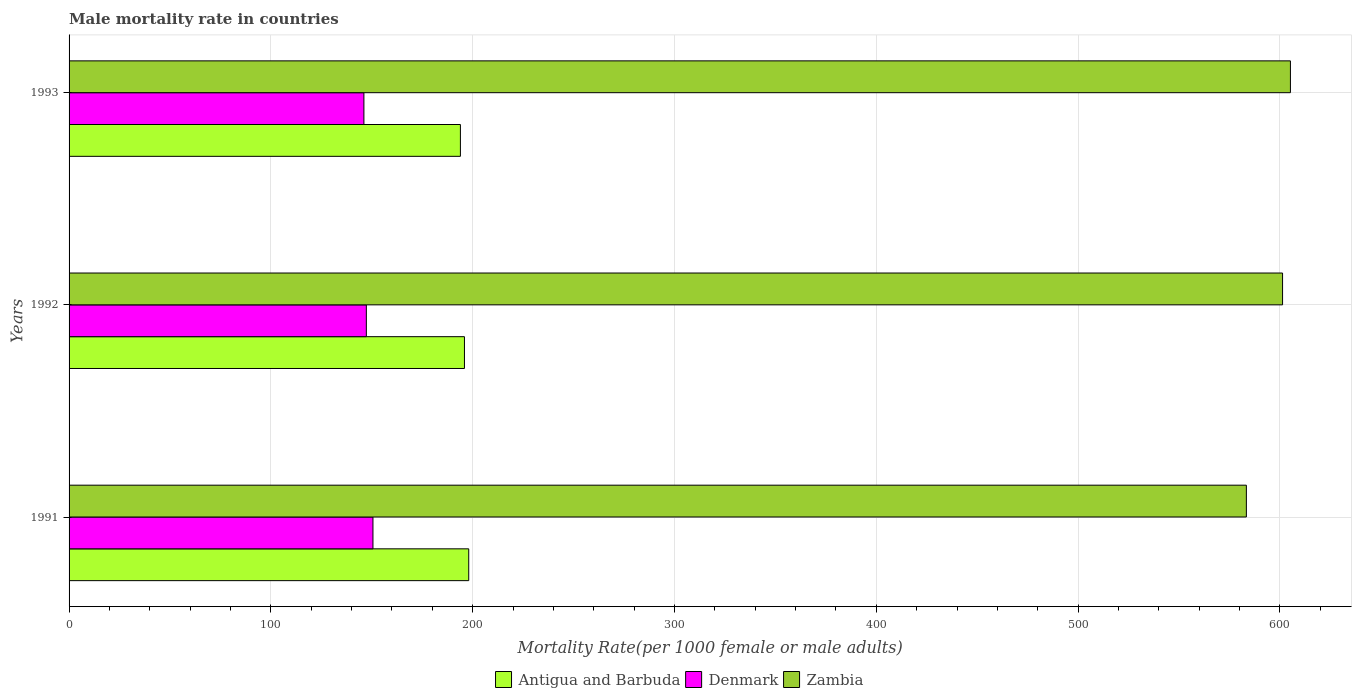How many different coloured bars are there?
Keep it short and to the point. 3. How many bars are there on the 3rd tick from the top?
Your answer should be very brief. 3. What is the label of the 3rd group of bars from the top?
Give a very brief answer. 1991. What is the male mortality rate in Denmark in 1991?
Your answer should be very brief. 150.57. Across all years, what is the maximum male mortality rate in Antigua and Barbuda?
Your answer should be very brief. 198.03. Across all years, what is the minimum male mortality rate in Denmark?
Give a very brief answer. 146.09. What is the total male mortality rate in Antigua and Barbuda in the graph?
Your answer should be very brief. 587.86. What is the difference between the male mortality rate in Denmark in 1991 and that in 1993?
Ensure brevity in your answer.  4.48. What is the difference between the male mortality rate in Denmark in 1993 and the male mortality rate in Zambia in 1991?
Your answer should be very brief. -437.27. What is the average male mortality rate in Denmark per year?
Your response must be concise. 147.99. In the year 1991, what is the difference between the male mortality rate in Antigua and Barbuda and male mortality rate in Denmark?
Your response must be concise. 47.46. In how many years, is the male mortality rate in Zambia greater than 140 ?
Your answer should be very brief. 3. What is the ratio of the male mortality rate in Denmark in 1992 to that in 1993?
Keep it short and to the point. 1.01. Is the male mortality rate in Zambia in 1992 less than that in 1993?
Keep it short and to the point. Yes. Is the difference between the male mortality rate in Antigua and Barbuda in 1991 and 1992 greater than the difference between the male mortality rate in Denmark in 1991 and 1992?
Offer a terse response. No. What is the difference between the highest and the second highest male mortality rate in Zambia?
Your answer should be compact. 3.9. What is the difference between the highest and the lowest male mortality rate in Denmark?
Your response must be concise. 4.48. Is the sum of the male mortality rate in Denmark in 1991 and 1992 greater than the maximum male mortality rate in Zambia across all years?
Ensure brevity in your answer.  No. What does the 3rd bar from the top in 1991 represents?
Provide a short and direct response. Antigua and Barbuda. What does the 3rd bar from the bottom in 1991 represents?
Ensure brevity in your answer.  Zambia. Are all the bars in the graph horizontal?
Keep it short and to the point. Yes. How many years are there in the graph?
Provide a short and direct response. 3. Does the graph contain any zero values?
Your answer should be very brief. No. Does the graph contain grids?
Your response must be concise. Yes. Where does the legend appear in the graph?
Offer a terse response. Bottom center. How many legend labels are there?
Your answer should be very brief. 3. What is the title of the graph?
Provide a short and direct response. Male mortality rate in countries. What is the label or title of the X-axis?
Offer a terse response. Mortality Rate(per 1000 female or male adults). What is the Mortality Rate(per 1000 female or male adults) in Antigua and Barbuda in 1991?
Your response must be concise. 198.03. What is the Mortality Rate(per 1000 female or male adults) in Denmark in 1991?
Offer a very short reply. 150.57. What is the Mortality Rate(per 1000 female or male adults) in Zambia in 1991?
Your answer should be compact. 583.36. What is the Mortality Rate(per 1000 female or male adults) of Antigua and Barbuda in 1992?
Ensure brevity in your answer.  195.91. What is the Mortality Rate(per 1000 female or male adults) in Denmark in 1992?
Keep it short and to the point. 147.3. What is the Mortality Rate(per 1000 female or male adults) of Zambia in 1992?
Make the answer very short. 601.29. What is the Mortality Rate(per 1000 female or male adults) in Antigua and Barbuda in 1993?
Your answer should be compact. 193.91. What is the Mortality Rate(per 1000 female or male adults) of Denmark in 1993?
Keep it short and to the point. 146.09. What is the Mortality Rate(per 1000 female or male adults) of Zambia in 1993?
Offer a very short reply. 605.19. Across all years, what is the maximum Mortality Rate(per 1000 female or male adults) of Antigua and Barbuda?
Give a very brief answer. 198.03. Across all years, what is the maximum Mortality Rate(per 1000 female or male adults) in Denmark?
Your response must be concise. 150.57. Across all years, what is the maximum Mortality Rate(per 1000 female or male adults) of Zambia?
Make the answer very short. 605.19. Across all years, what is the minimum Mortality Rate(per 1000 female or male adults) in Antigua and Barbuda?
Your answer should be compact. 193.91. Across all years, what is the minimum Mortality Rate(per 1000 female or male adults) of Denmark?
Ensure brevity in your answer.  146.09. Across all years, what is the minimum Mortality Rate(per 1000 female or male adults) in Zambia?
Offer a very short reply. 583.36. What is the total Mortality Rate(per 1000 female or male adults) in Antigua and Barbuda in the graph?
Your answer should be compact. 587.86. What is the total Mortality Rate(per 1000 female or male adults) of Denmark in the graph?
Offer a terse response. 443.96. What is the total Mortality Rate(per 1000 female or male adults) of Zambia in the graph?
Make the answer very short. 1789.85. What is the difference between the Mortality Rate(per 1000 female or male adults) of Antigua and Barbuda in 1991 and that in 1992?
Make the answer very short. 2.12. What is the difference between the Mortality Rate(per 1000 female or male adults) in Denmark in 1991 and that in 1992?
Your answer should be compact. 3.28. What is the difference between the Mortality Rate(per 1000 female or male adults) of Zambia in 1991 and that in 1992?
Give a very brief answer. -17.93. What is the difference between the Mortality Rate(per 1000 female or male adults) of Antigua and Barbuda in 1991 and that in 1993?
Give a very brief answer. 4.12. What is the difference between the Mortality Rate(per 1000 female or male adults) in Denmark in 1991 and that in 1993?
Offer a terse response. 4.48. What is the difference between the Mortality Rate(per 1000 female or male adults) of Zambia in 1991 and that in 1993?
Your answer should be compact. -21.83. What is the difference between the Mortality Rate(per 1000 female or male adults) in Antigua and Barbuda in 1992 and that in 1993?
Keep it short and to the point. 2. What is the difference between the Mortality Rate(per 1000 female or male adults) of Denmark in 1992 and that in 1993?
Provide a short and direct response. 1.21. What is the difference between the Mortality Rate(per 1000 female or male adults) of Zambia in 1992 and that in 1993?
Provide a short and direct response. -3.9. What is the difference between the Mortality Rate(per 1000 female or male adults) of Antigua and Barbuda in 1991 and the Mortality Rate(per 1000 female or male adults) of Denmark in 1992?
Your answer should be very brief. 50.73. What is the difference between the Mortality Rate(per 1000 female or male adults) in Antigua and Barbuda in 1991 and the Mortality Rate(per 1000 female or male adults) in Zambia in 1992?
Keep it short and to the point. -403.26. What is the difference between the Mortality Rate(per 1000 female or male adults) in Denmark in 1991 and the Mortality Rate(per 1000 female or male adults) in Zambia in 1992?
Ensure brevity in your answer.  -450.72. What is the difference between the Mortality Rate(per 1000 female or male adults) in Antigua and Barbuda in 1991 and the Mortality Rate(per 1000 female or male adults) in Denmark in 1993?
Ensure brevity in your answer.  51.94. What is the difference between the Mortality Rate(per 1000 female or male adults) of Antigua and Barbuda in 1991 and the Mortality Rate(per 1000 female or male adults) of Zambia in 1993?
Ensure brevity in your answer.  -407.16. What is the difference between the Mortality Rate(per 1000 female or male adults) of Denmark in 1991 and the Mortality Rate(per 1000 female or male adults) of Zambia in 1993?
Give a very brief answer. -454.62. What is the difference between the Mortality Rate(per 1000 female or male adults) of Antigua and Barbuda in 1992 and the Mortality Rate(per 1000 female or male adults) of Denmark in 1993?
Give a very brief answer. 49.82. What is the difference between the Mortality Rate(per 1000 female or male adults) in Antigua and Barbuda in 1992 and the Mortality Rate(per 1000 female or male adults) in Zambia in 1993?
Keep it short and to the point. -409.28. What is the difference between the Mortality Rate(per 1000 female or male adults) of Denmark in 1992 and the Mortality Rate(per 1000 female or male adults) of Zambia in 1993?
Your response must be concise. -457.89. What is the average Mortality Rate(per 1000 female or male adults) of Antigua and Barbuda per year?
Give a very brief answer. 195.95. What is the average Mortality Rate(per 1000 female or male adults) in Denmark per year?
Your response must be concise. 147.99. What is the average Mortality Rate(per 1000 female or male adults) of Zambia per year?
Make the answer very short. 596.62. In the year 1991, what is the difference between the Mortality Rate(per 1000 female or male adults) of Antigua and Barbuda and Mortality Rate(per 1000 female or male adults) of Denmark?
Give a very brief answer. 47.46. In the year 1991, what is the difference between the Mortality Rate(per 1000 female or male adults) in Antigua and Barbuda and Mortality Rate(per 1000 female or male adults) in Zambia?
Ensure brevity in your answer.  -385.33. In the year 1991, what is the difference between the Mortality Rate(per 1000 female or male adults) in Denmark and Mortality Rate(per 1000 female or male adults) in Zambia?
Offer a terse response. -432.79. In the year 1992, what is the difference between the Mortality Rate(per 1000 female or male adults) of Antigua and Barbuda and Mortality Rate(per 1000 female or male adults) of Denmark?
Your response must be concise. 48.62. In the year 1992, what is the difference between the Mortality Rate(per 1000 female or male adults) in Antigua and Barbuda and Mortality Rate(per 1000 female or male adults) in Zambia?
Offer a very short reply. -405.38. In the year 1992, what is the difference between the Mortality Rate(per 1000 female or male adults) of Denmark and Mortality Rate(per 1000 female or male adults) of Zambia?
Offer a very short reply. -454. In the year 1993, what is the difference between the Mortality Rate(per 1000 female or male adults) in Antigua and Barbuda and Mortality Rate(per 1000 female or male adults) in Denmark?
Offer a terse response. 47.82. In the year 1993, what is the difference between the Mortality Rate(per 1000 female or male adults) in Antigua and Barbuda and Mortality Rate(per 1000 female or male adults) in Zambia?
Your answer should be very brief. -411.28. In the year 1993, what is the difference between the Mortality Rate(per 1000 female or male adults) of Denmark and Mortality Rate(per 1000 female or male adults) of Zambia?
Provide a short and direct response. -459.1. What is the ratio of the Mortality Rate(per 1000 female or male adults) in Antigua and Barbuda in 1991 to that in 1992?
Offer a terse response. 1.01. What is the ratio of the Mortality Rate(per 1000 female or male adults) of Denmark in 1991 to that in 1992?
Your answer should be compact. 1.02. What is the ratio of the Mortality Rate(per 1000 female or male adults) in Zambia in 1991 to that in 1992?
Provide a short and direct response. 0.97. What is the ratio of the Mortality Rate(per 1000 female or male adults) in Antigua and Barbuda in 1991 to that in 1993?
Keep it short and to the point. 1.02. What is the ratio of the Mortality Rate(per 1000 female or male adults) of Denmark in 1991 to that in 1993?
Keep it short and to the point. 1.03. What is the ratio of the Mortality Rate(per 1000 female or male adults) of Zambia in 1991 to that in 1993?
Make the answer very short. 0.96. What is the ratio of the Mortality Rate(per 1000 female or male adults) in Antigua and Barbuda in 1992 to that in 1993?
Your answer should be compact. 1.01. What is the ratio of the Mortality Rate(per 1000 female or male adults) of Denmark in 1992 to that in 1993?
Your answer should be compact. 1.01. What is the ratio of the Mortality Rate(per 1000 female or male adults) in Zambia in 1992 to that in 1993?
Offer a very short reply. 0.99. What is the difference between the highest and the second highest Mortality Rate(per 1000 female or male adults) in Antigua and Barbuda?
Your answer should be compact. 2.12. What is the difference between the highest and the second highest Mortality Rate(per 1000 female or male adults) in Denmark?
Your answer should be very brief. 3.28. What is the difference between the highest and the second highest Mortality Rate(per 1000 female or male adults) in Zambia?
Give a very brief answer. 3.9. What is the difference between the highest and the lowest Mortality Rate(per 1000 female or male adults) in Antigua and Barbuda?
Provide a succinct answer. 4.12. What is the difference between the highest and the lowest Mortality Rate(per 1000 female or male adults) of Denmark?
Provide a succinct answer. 4.48. What is the difference between the highest and the lowest Mortality Rate(per 1000 female or male adults) of Zambia?
Your answer should be very brief. 21.83. 